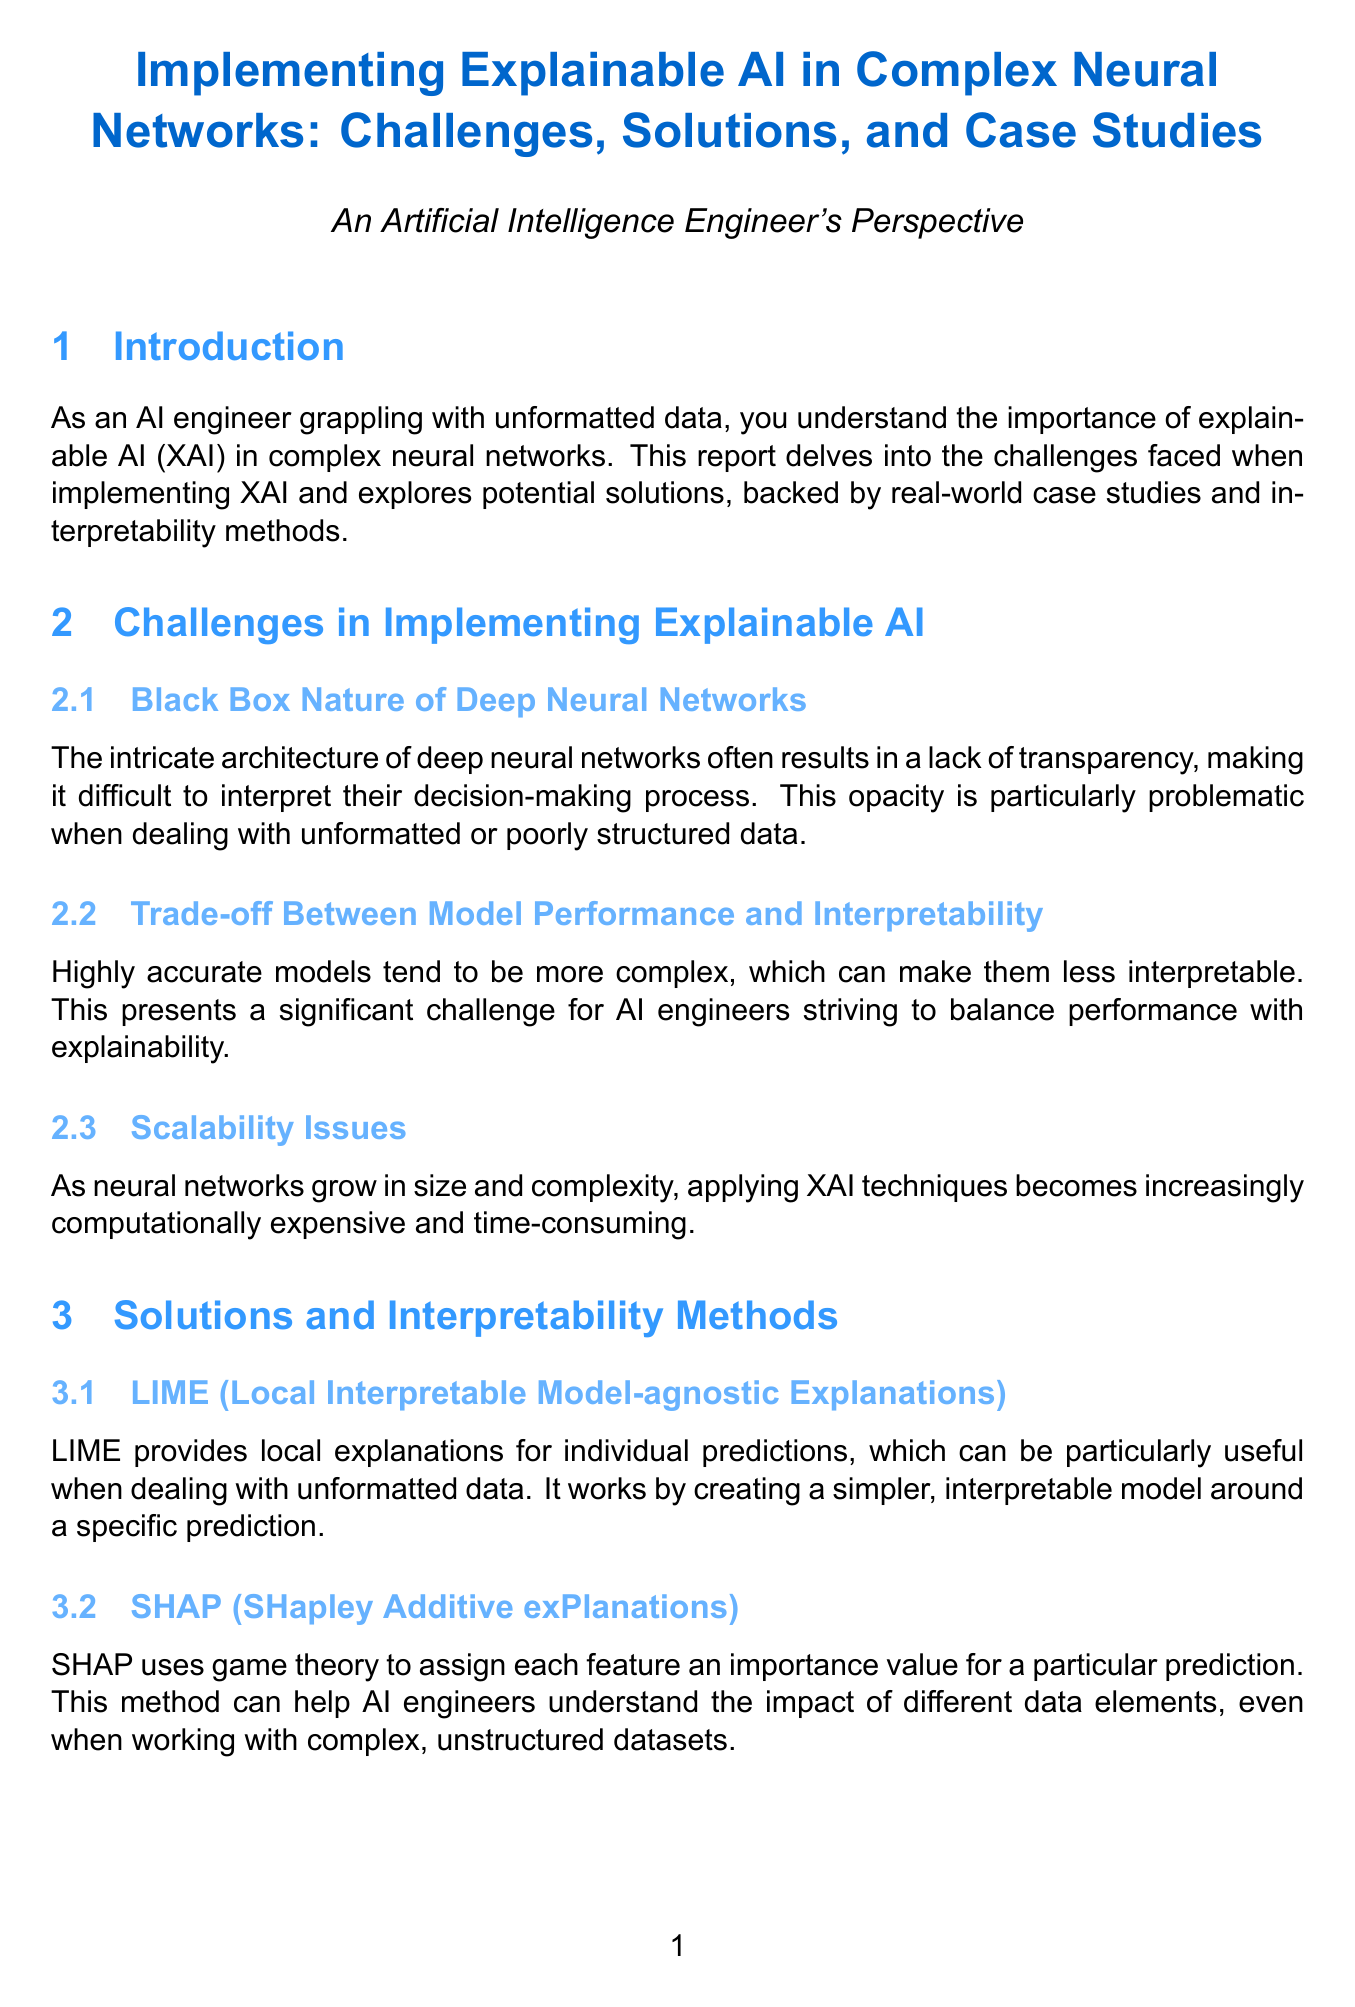What is the title of the report? The title is explicitly stated in the document's title section.
Answer: Implementing Explainable AI in Complex Neural Networks: Challenges, Solutions, and Case Studies What are the three main challenges in implementing explainable AI? The document lists three specific challenges in a dedicated section, including their titles.
Answer: Black Box Nature of Deep Neural Networks, Trade-off Between Model Performance and Interpretability, Scalability Issues Which interpretability method uses game theory? The document describes interpretability methods and indicates which one utilizes game theory for explanations.
Answer: SHAP What case study explores IBM's implementation of XAI? The document mentions various case studies and specifies the one related to IBM Watson.
Answer: IBM Watson for Oncology What is a future research area mentioned in the report? The report concludes with future directions in research, discussing one area explicitly.
Answer: Neuro-symbolic AI What framework provides local explanations for individual predictions? The document presents interpretability methods and highlights one that provides local explanations.
Answer: LIME 